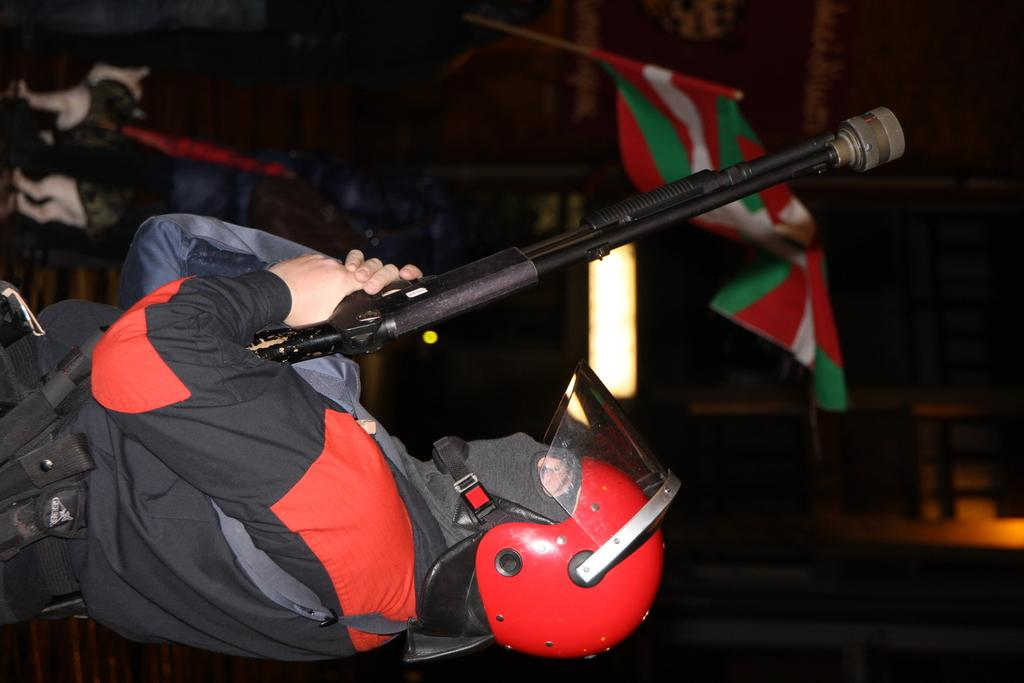What is the main subject of the image? The main subject of the image is a man. What is the man wearing in the image? The man is wearing a helmet in the image. What is the man holding in the image? The man is holding a gun in the image. What can be seen in the background of the image? There is a light, a flag, and a dog in the background of the image. What type of cabbage is being used as a prop in the image? There is no cabbage present in the image. How many trees can be seen in the background of the image? There are no trees visible in the background of the image. 